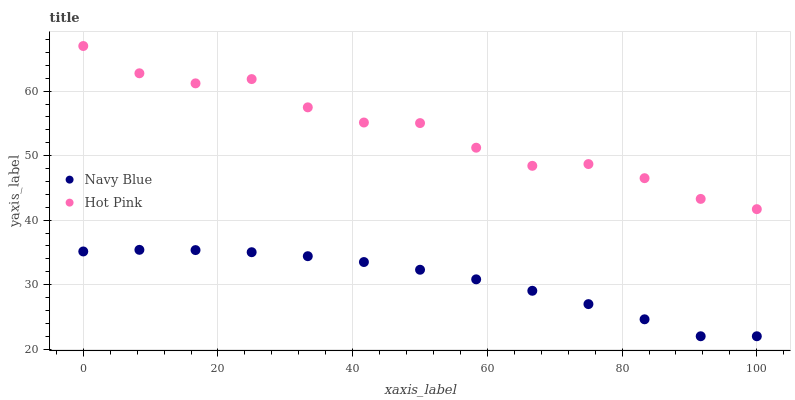Does Navy Blue have the minimum area under the curve?
Answer yes or no. Yes. Does Hot Pink have the maximum area under the curve?
Answer yes or no. Yes. Does Hot Pink have the minimum area under the curve?
Answer yes or no. No. Is Navy Blue the smoothest?
Answer yes or no. Yes. Is Hot Pink the roughest?
Answer yes or no. Yes. Is Hot Pink the smoothest?
Answer yes or no. No. Does Navy Blue have the lowest value?
Answer yes or no. Yes. Does Hot Pink have the lowest value?
Answer yes or no. No. Does Hot Pink have the highest value?
Answer yes or no. Yes. Is Navy Blue less than Hot Pink?
Answer yes or no. Yes. Is Hot Pink greater than Navy Blue?
Answer yes or no. Yes. Does Navy Blue intersect Hot Pink?
Answer yes or no. No. 